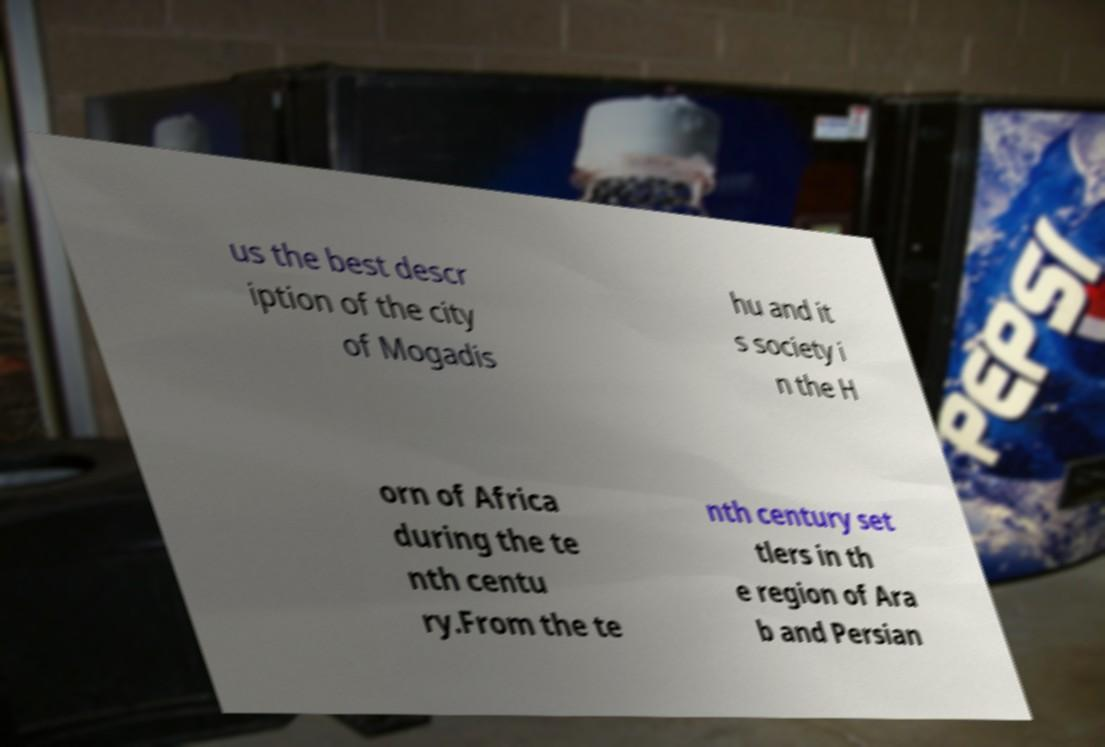Please read and relay the text visible in this image. What does it say? us the best descr iption of the city of Mogadis hu and it s society i n the H orn of Africa during the te nth centu ry.From the te nth century set tlers in th e region of Ara b and Persian 